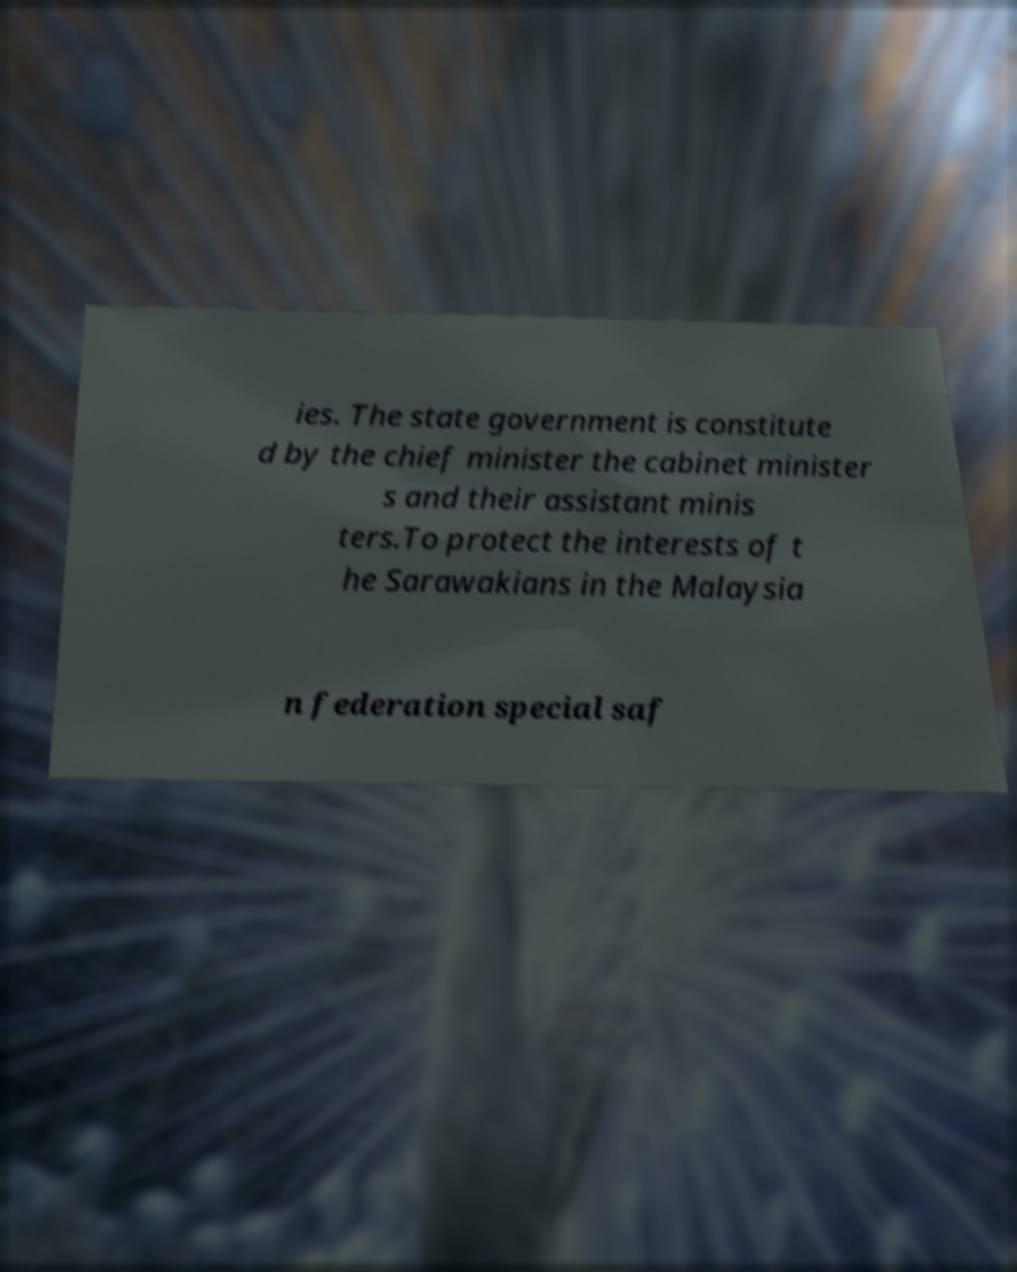There's text embedded in this image that I need extracted. Can you transcribe it verbatim? ies. The state government is constitute d by the chief minister the cabinet minister s and their assistant minis ters.To protect the interests of t he Sarawakians in the Malaysia n federation special saf 